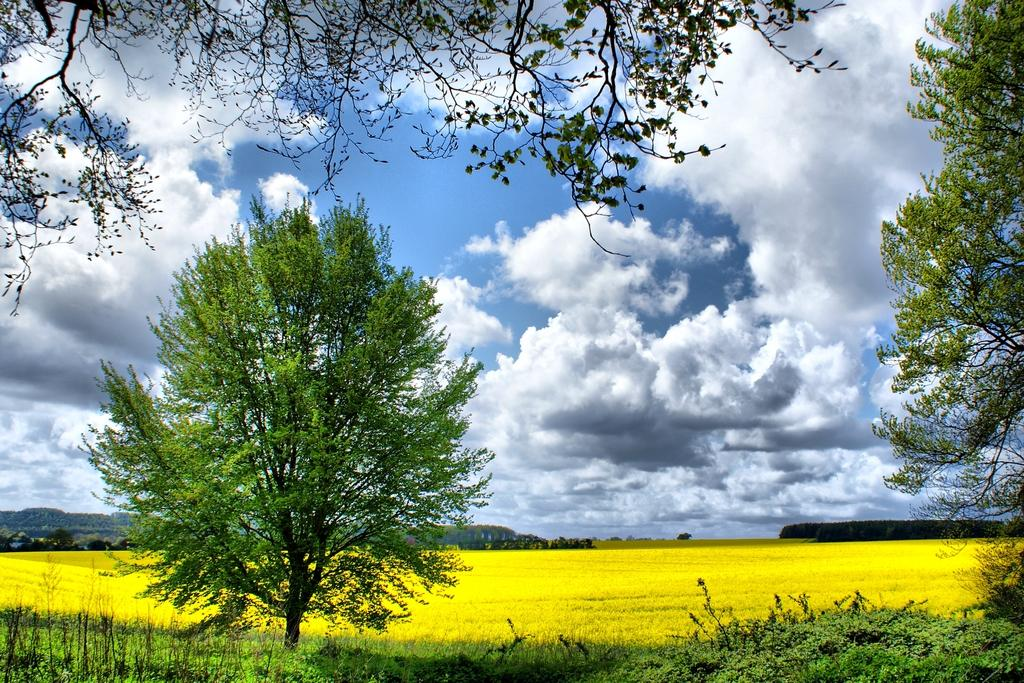What type of vegetation can be seen in the image? There are trees in the image. What else can be seen on the ground in the image? There is grass in the image. What is visible in the background of the image? The sky is visible in the background of the image. What can be seen in the sky in the background of the image? There are clouds in the sky in the background of the image. How many beds are visible in the image? There are no beds present in the image. What type of boundary can be seen in the image? There is no boundary visible in the image. 